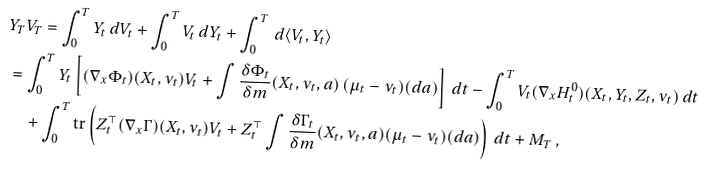<formula> <loc_0><loc_0><loc_500><loc_500>& Y _ { T } V _ { T } = \int _ { 0 } ^ { T } Y _ { t } \, d V _ { t } + \int _ { 0 } ^ { T } V _ { t } \, d Y _ { t } + \int _ { 0 } ^ { T } \, d \langle V _ { t } , Y _ { t } \rangle \\ & = \int _ { 0 } ^ { T } Y _ { t } \left [ ( \nabla _ { x } \Phi _ { t } ) ( X _ { t } , \nu _ { t } ) V _ { t } + \int \frac { \delta \Phi _ { t } } { \delta m } ( X _ { t } , \nu _ { t } , a ) \, ( \mu _ { t } - \nu _ { t } ) ( d a ) \right ] \, d t - \int _ { 0 } ^ { T } V _ { t } ( \nabla _ { x } H ^ { 0 } _ { t } ) ( X _ { t } , Y _ { t } , Z _ { t } , \nu _ { t } ) \, d t \\ & \quad + \int _ { 0 } ^ { T } \text {tr} \left ( Z _ { t } ^ { \top } ( \nabla _ { x } \Gamma ) ( X _ { t } , \nu _ { t } ) V _ { t } + Z _ { t } ^ { \top } \int \frac { \delta \Gamma _ { t } } { \delta m } ( X _ { t } , \nu _ { t } , a ) ( \mu _ { t } - \nu _ { t } ) ( d a ) \right ) \, d t + M _ { T } \, ,</formula> 